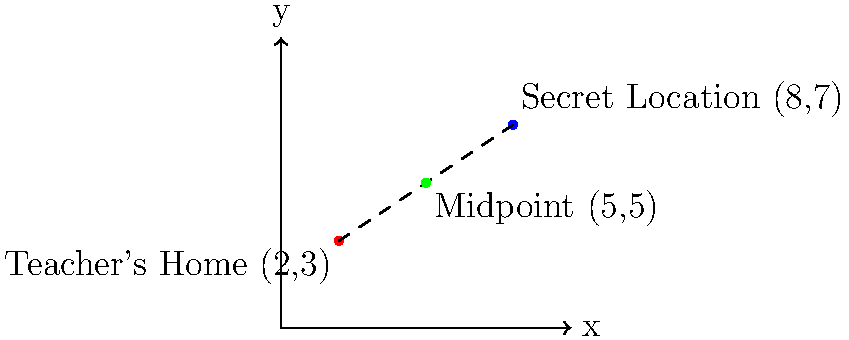As an event planner organizing a surprise outing for a teacher, you need to determine the midpoint between the teacher's home and the secret location. Given that the teacher's home is at coordinates (2,3) and the secret location is at (8,7), what are the coordinates of the midpoint? To find the midpoint between two points, we use the midpoint formula:

$$ \text{Midpoint} = \left(\frac{x_1 + x_2}{2}, \frac{y_1 + y_2}{2}\right) $$

Where $(x_1, y_1)$ is the first point and $(x_2, y_2)$ is the second point.

Step 1: Identify the coordinates
- Teacher's home: $(x_1, y_1) = (2, 3)$
- Secret location: $(x_2, y_2) = (8, 7)$

Step 2: Calculate the x-coordinate of the midpoint
$$ x_{midpoint} = \frac{x_1 + x_2}{2} = \frac{2 + 8}{2} = \frac{10}{2} = 5 $$

Step 3: Calculate the y-coordinate of the midpoint
$$ y_{midpoint} = \frac{y_1 + y_2}{2} = \frac{3 + 7}{2} = \frac{10}{2} = 5 $$

Step 4: Combine the results
The midpoint coordinates are $(5, 5)$.
Answer: (5, 5) 